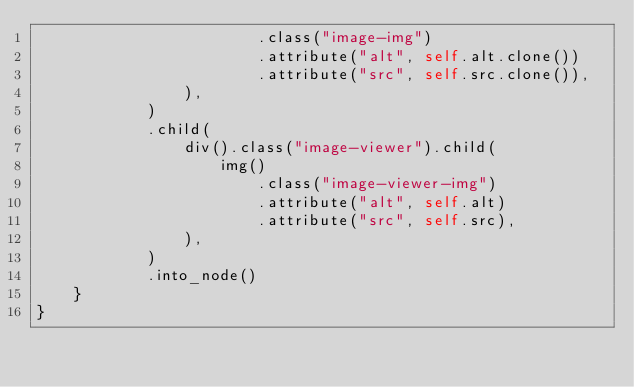Convert code to text. <code><loc_0><loc_0><loc_500><loc_500><_Rust_>						.class("image-img")
						.attribute("alt", self.alt.clone())
						.attribute("src", self.src.clone()),
				),
			)
			.child(
				div().class("image-viewer").child(
					img()
						.class("image-viewer-img")
						.attribute("alt", self.alt)
						.attribute("src", self.src),
				),
			)
			.into_node()
	}
}
</code> 